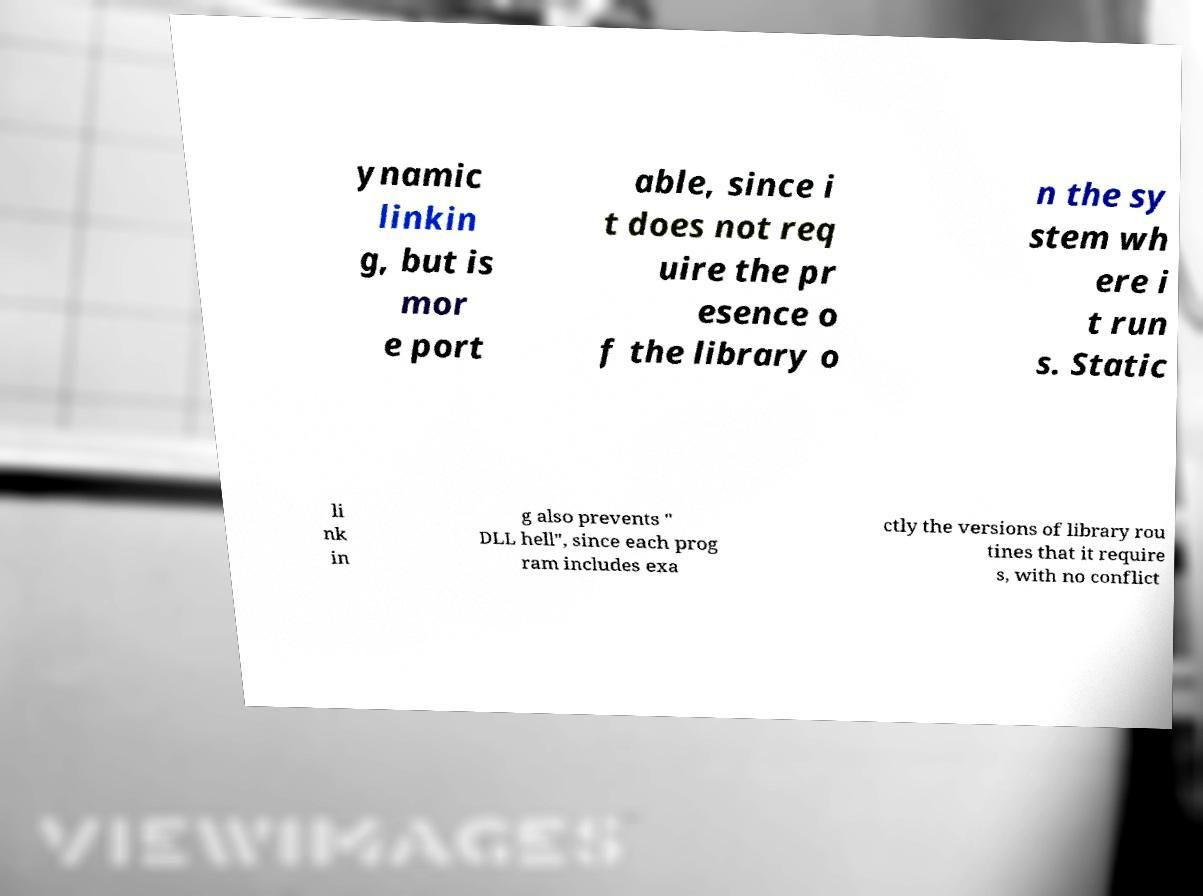Can you read and provide the text displayed in the image?This photo seems to have some interesting text. Can you extract and type it out for me? ynamic linkin g, but is mor e port able, since i t does not req uire the pr esence o f the library o n the sy stem wh ere i t run s. Static li nk in g also prevents " DLL hell", since each prog ram includes exa ctly the versions of library rou tines that it require s, with no conflict 